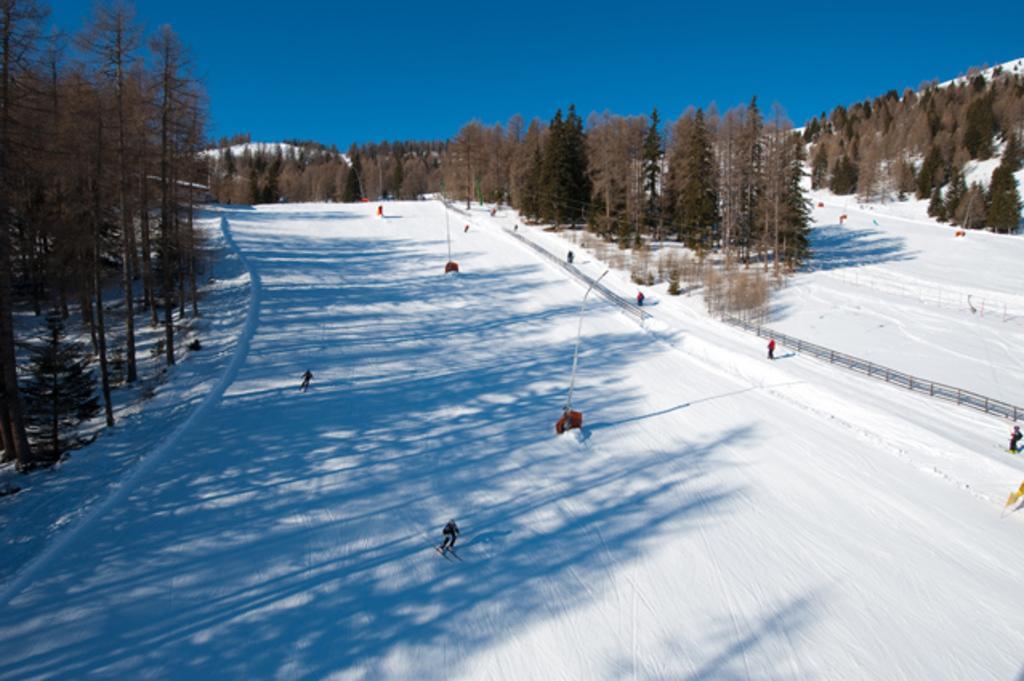Describe this image in one or two sentences. In this image there is snow in the middle. There are few people who are skiing in the snow. On the left side there is a wooden fence in the snow. In the background there are trees. At the top there is the sky. In the middle there are two poles in the snow. 